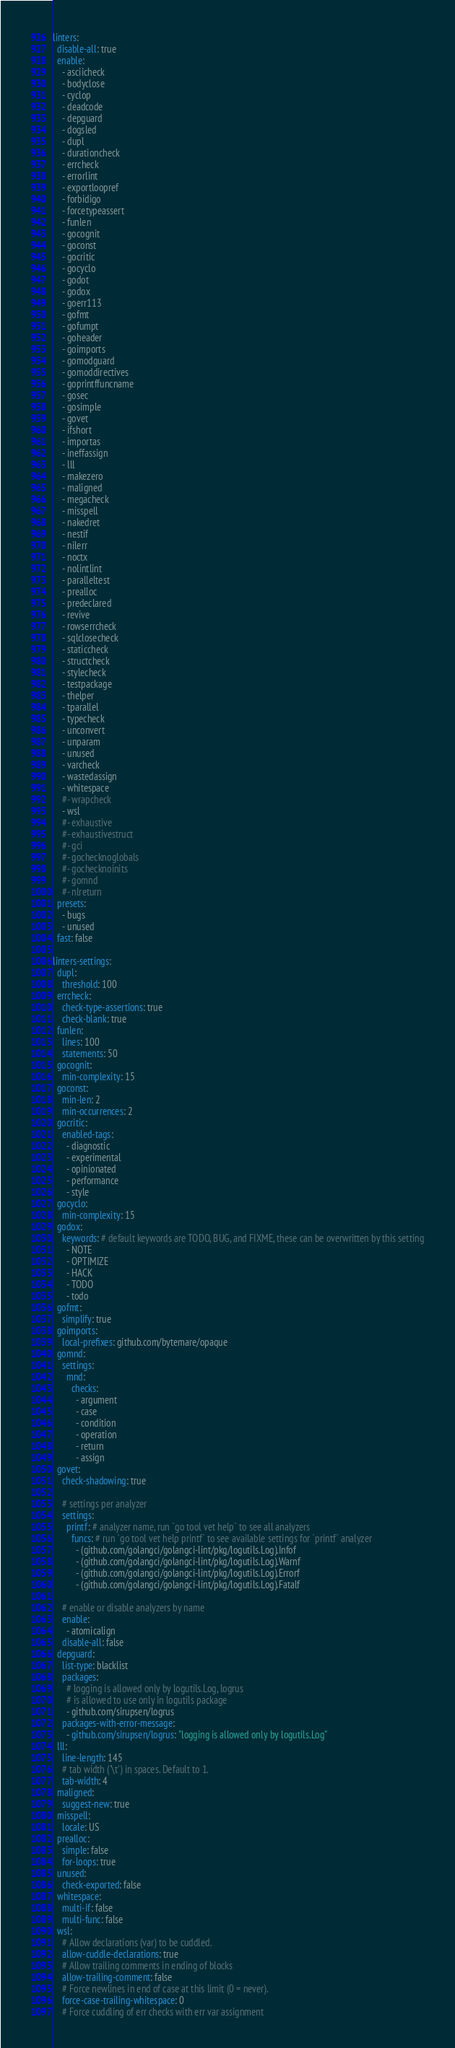Convert code to text. <code><loc_0><loc_0><loc_500><loc_500><_YAML_>linters:
  disable-all: true
  enable:
    - asciicheck
    - bodyclose
    - cyclop
    - deadcode
    - depguard
    - dogsled
    - dupl
    - durationcheck
    - errcheck
    - errorlint
    - exportloopref
    - forbidigo
    - forcetypeassert
    - funlen
    - gocognit
    - goconst
    - gocritic
    - gocyclo
    - godot
    - godox
    - goerr113
    - gofmt
    - gofumpt
    - goheader
    - goimports
    - gomodguard
    - gomoddirectives
    - goprintffuncname
    - gosec
    - gosimple
    - govet
    - ifshort
    - importas
    - ineffassign
    - lll
    - makezero
    - maligned
    - megacheck
    - misspell
    - nakedret
    - nestif
    - nilerr
    - noctx
    - nolintlint
    - paralleltest
    - prealloc
    - predeclared
    - revive
    - rowserrcheck
    - sqlclosecheck
    - staticcheck
    - structcheck
    - stylecheck
    - testpackage
    - thelper
    - tparallel
    - typecheck
    - unconvert
    - unparam
    - unused
    - varcheck
    - wastedassign
    - whitespace
    #- wrapcheck
    - wsl
    #- exhaustive
    #- exhaustivestruct
    #- gci
    #- gochecknoglobals
    #- gochecknoinits
    #- gomnd
    #- nlreturn
  presets:
    - bugs
    - unused
  fast: false

linters-settings:
  dupl:
    threshold: 100
  errcheck:
    check-type-assertions: true
    check-blank: true
  funlen:
    lines: 100
    statements: 50
  gocognit:
    min-complexity: 15
  goconst:
    min-len: 2
    min-occurrences: 2
  gocritic:
    enabled-tags:
      - diagnostic
      - experimental
      - opinionated
      - performance
      - style
  gocyclo:
    min-complexity: 15
  godox:
    keywords: # default keywords are TODO, BUG, and FIXME, these can be overwritten by this setting
      - NOTE
      - OPTIMIZE
      - HACK
      - TODO
      - todo
  gofmt:
    simplify: true
  goimports:
    local-prefixes: github.com/bytemare/opaque
  gomnd:
    settings:
      mnd:
        checks:
          - argument
          - case
          - condition
          - operation
          - return
          - assign
  govet:
    check-shadowing: true

    # settings per analyzer
    settings:
      printf: # analyzer name, run `go tool vet help` to see all analyzers
        funcs: # run `go tool vet help printf` to see available settings for `printf` analyzer
          - (github.com/golangci/golangci-lint/pkg/logutils.Log).Infof
          - (github.com/golangci/golangci-lint/pkg/logutils.Log).Warnf
          - (github.com/golangci/golangci-lint/pkg/logutils.Log).Errorf
          - (github.com/golangci/golangci-lint/pkg/logutils.Log).Fatalf

    # enable or disable analyzers by name
    enable:
      - atomicalign
    disable-all: false
  depguard:
    list-type: blacklist
    packages:
      # logging is allowed only by logutils.Log, logrus
      # is allowed to use only in logutils package
      - github.com/sirupsen/logrus
    packages-with-error-message:
      - github.com/sirupsen/logrus: "logging is allowed only by logutils.Log"
  lll:
    line-length: 145
    # tab width ('\t') in spaces. Default to 1.
    tab-width: 4
  maligned:
    suggest-new: true
  misspell:
    locale: US
  prealloc:
    simple: false
    for-loops: true
  unused:
    check-exported: false
  whitespace:
    multi-if: false
    multi-func: false
  wsl:
    # Allow declarations (var) to be cuddled.
    allow-cuddle-declarations: true
    # Allow trailing comments in ending of blocks
    allow-trailing-comment: false
    # Force newlines in end of case at this limit (0 = never).
    force-case-trailing-whitespace: 0
    # Force cuddling of err checks with err var assignment</code> 